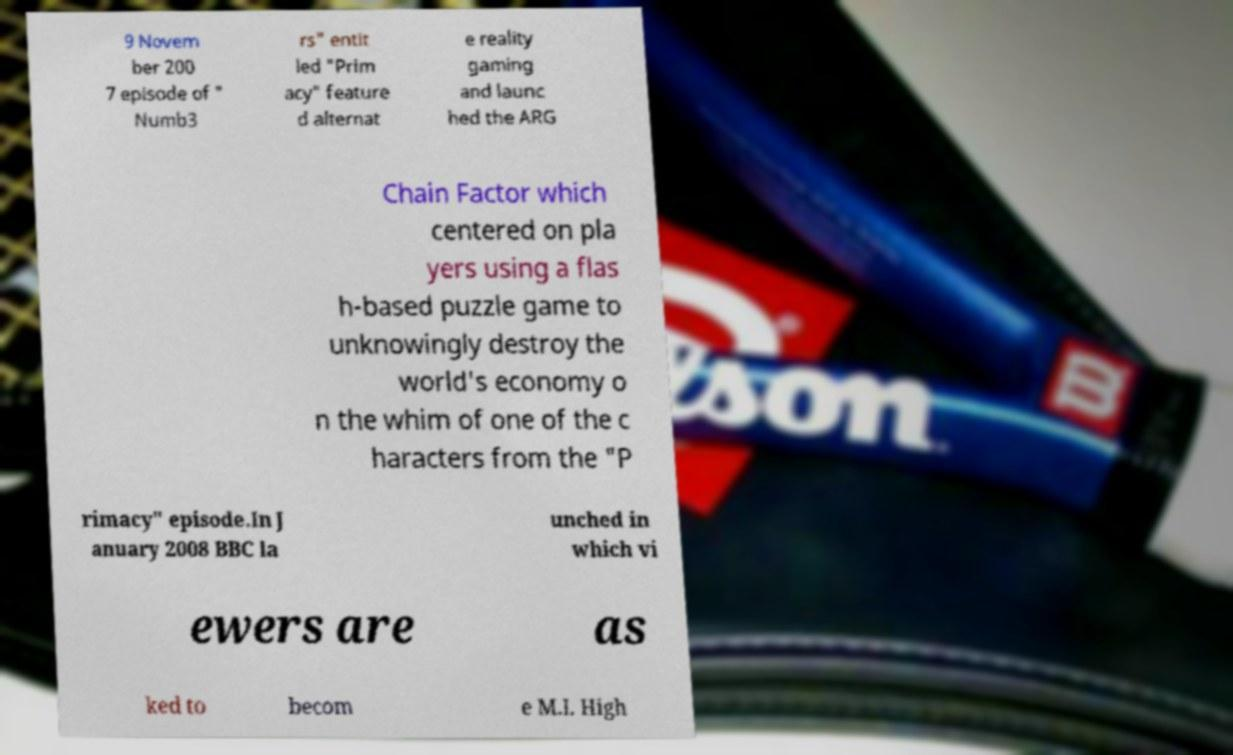For documentation purposes, I need the text within this image transcribed. Could you provide that? 9 Novem ber 200 7 episode of " Numb3 rs" entit led "Prim acy" feature d alternat e reality gaming and launc hed the ARG Chain Factor which centered on pla yers using a flas h-based puzzle game to unknowingly destroy the world's economy o n the whim of one of the c haracters from the "P rimacy" episode.In J anuary 2008 BBC la unched in which vi ewers are as ked to becom e M.I. High 